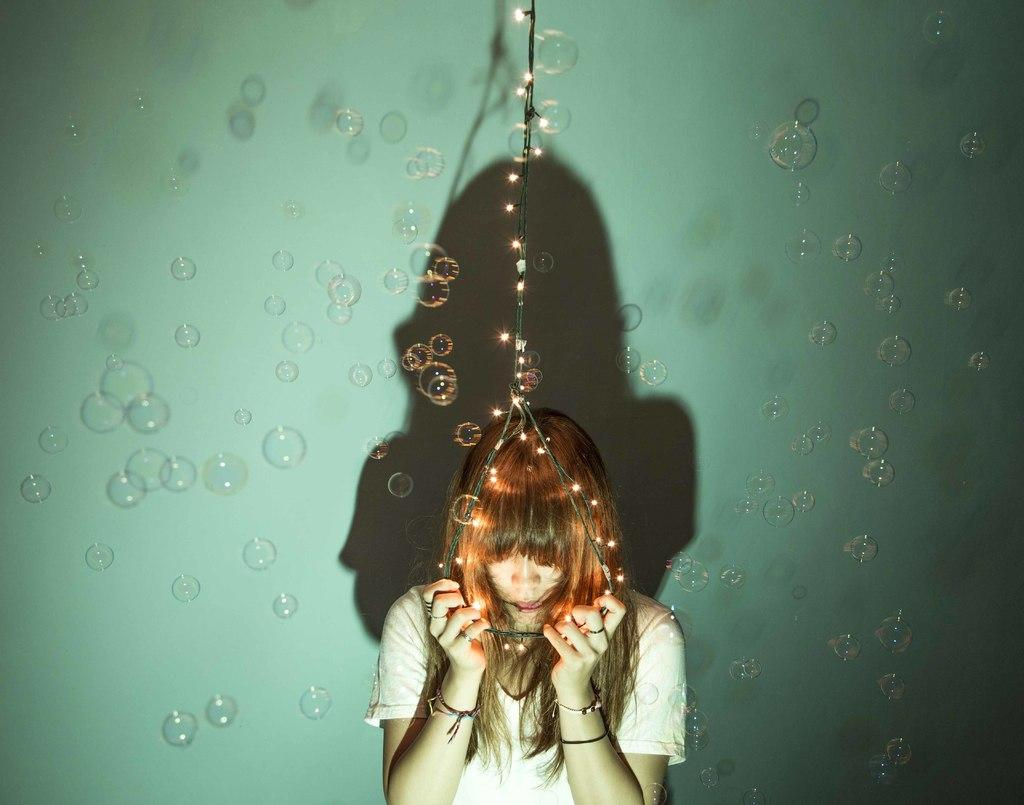What can be seen in the image that is related to air? There are air bubbles in the image. What is the woman doing in the image? The woman is standing in the image and holding a wire with her hands. What is attached to the wire that the woman is holding? There are lights attached to the wire. What type of trousers is the woman wearing in the image? The provided facts do not mention the woman's trousers, so we cannot determine the type of trousers she is wearing. How does the woman's behavior change throughout the image? The provided facts do not mention any changes in the woman's behavior, so we cannot determine how her behavior changes throughout the image. 